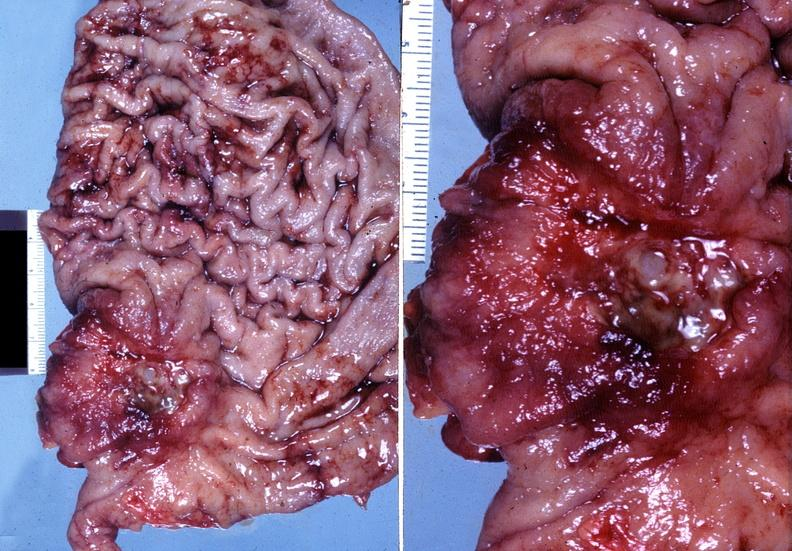does this image show stomach, adenocarcinoma?
Answer the question using a single word or phrase. Yes 